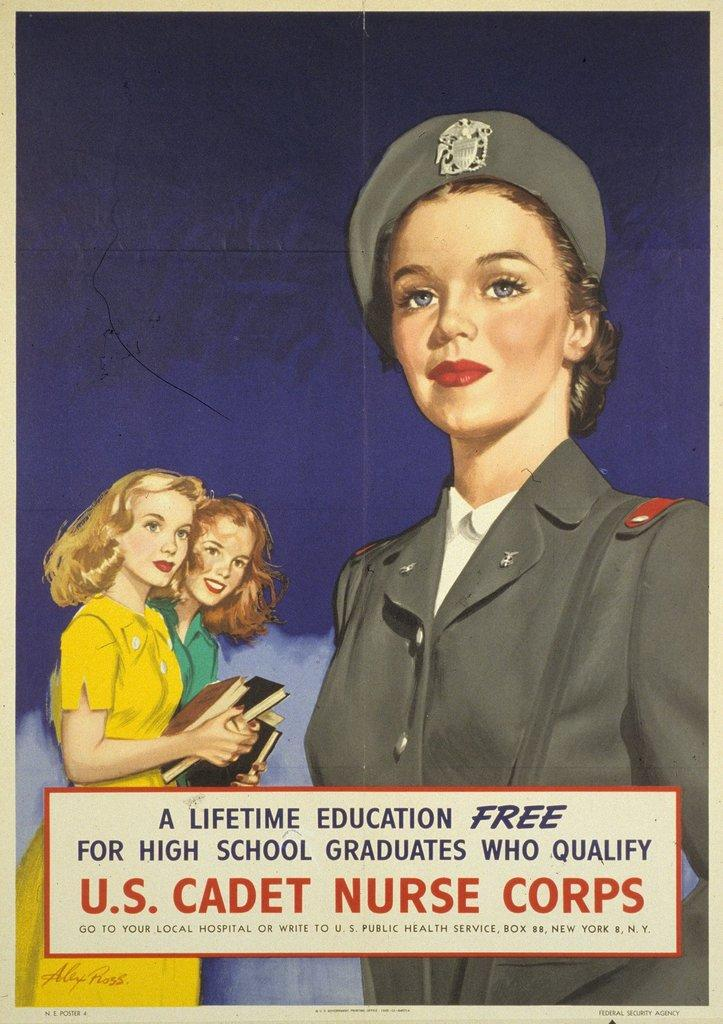What is the main subject of the image? The main subject of the image is a poster. What can be seen on the poster? The poster contains images of three women. Is there any text on the poster? Yes, there is text at the bottom of the image. What are the women in the poster doing? Two of the women in the poster are holding books in their hands. What type of weather can be seen in the image? There is no weather depicted in the image, as it is a poster featuring images of three women. Is the queen present in the image? There is no queen present in the image; it features three women, but there is no indication that any of them are royalty. 